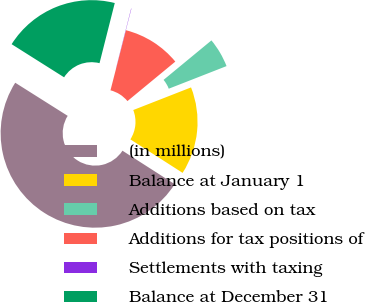<chart> <loc_0><loc_0><loc_500><loc_500><pie_chart><fcel>(in millions)<fcel>Balance at January 1<fcel>Additions based on tax<fcel>Additions for tax positions of<fcel>Settlements with taxing<fcel>Balance at December 31<nl><fcel>49.89%<fcel>15.01%<fcel>5.04%<fcel>10.02%<fcel>0.05%<fcel>19.99%<nl></chart> 